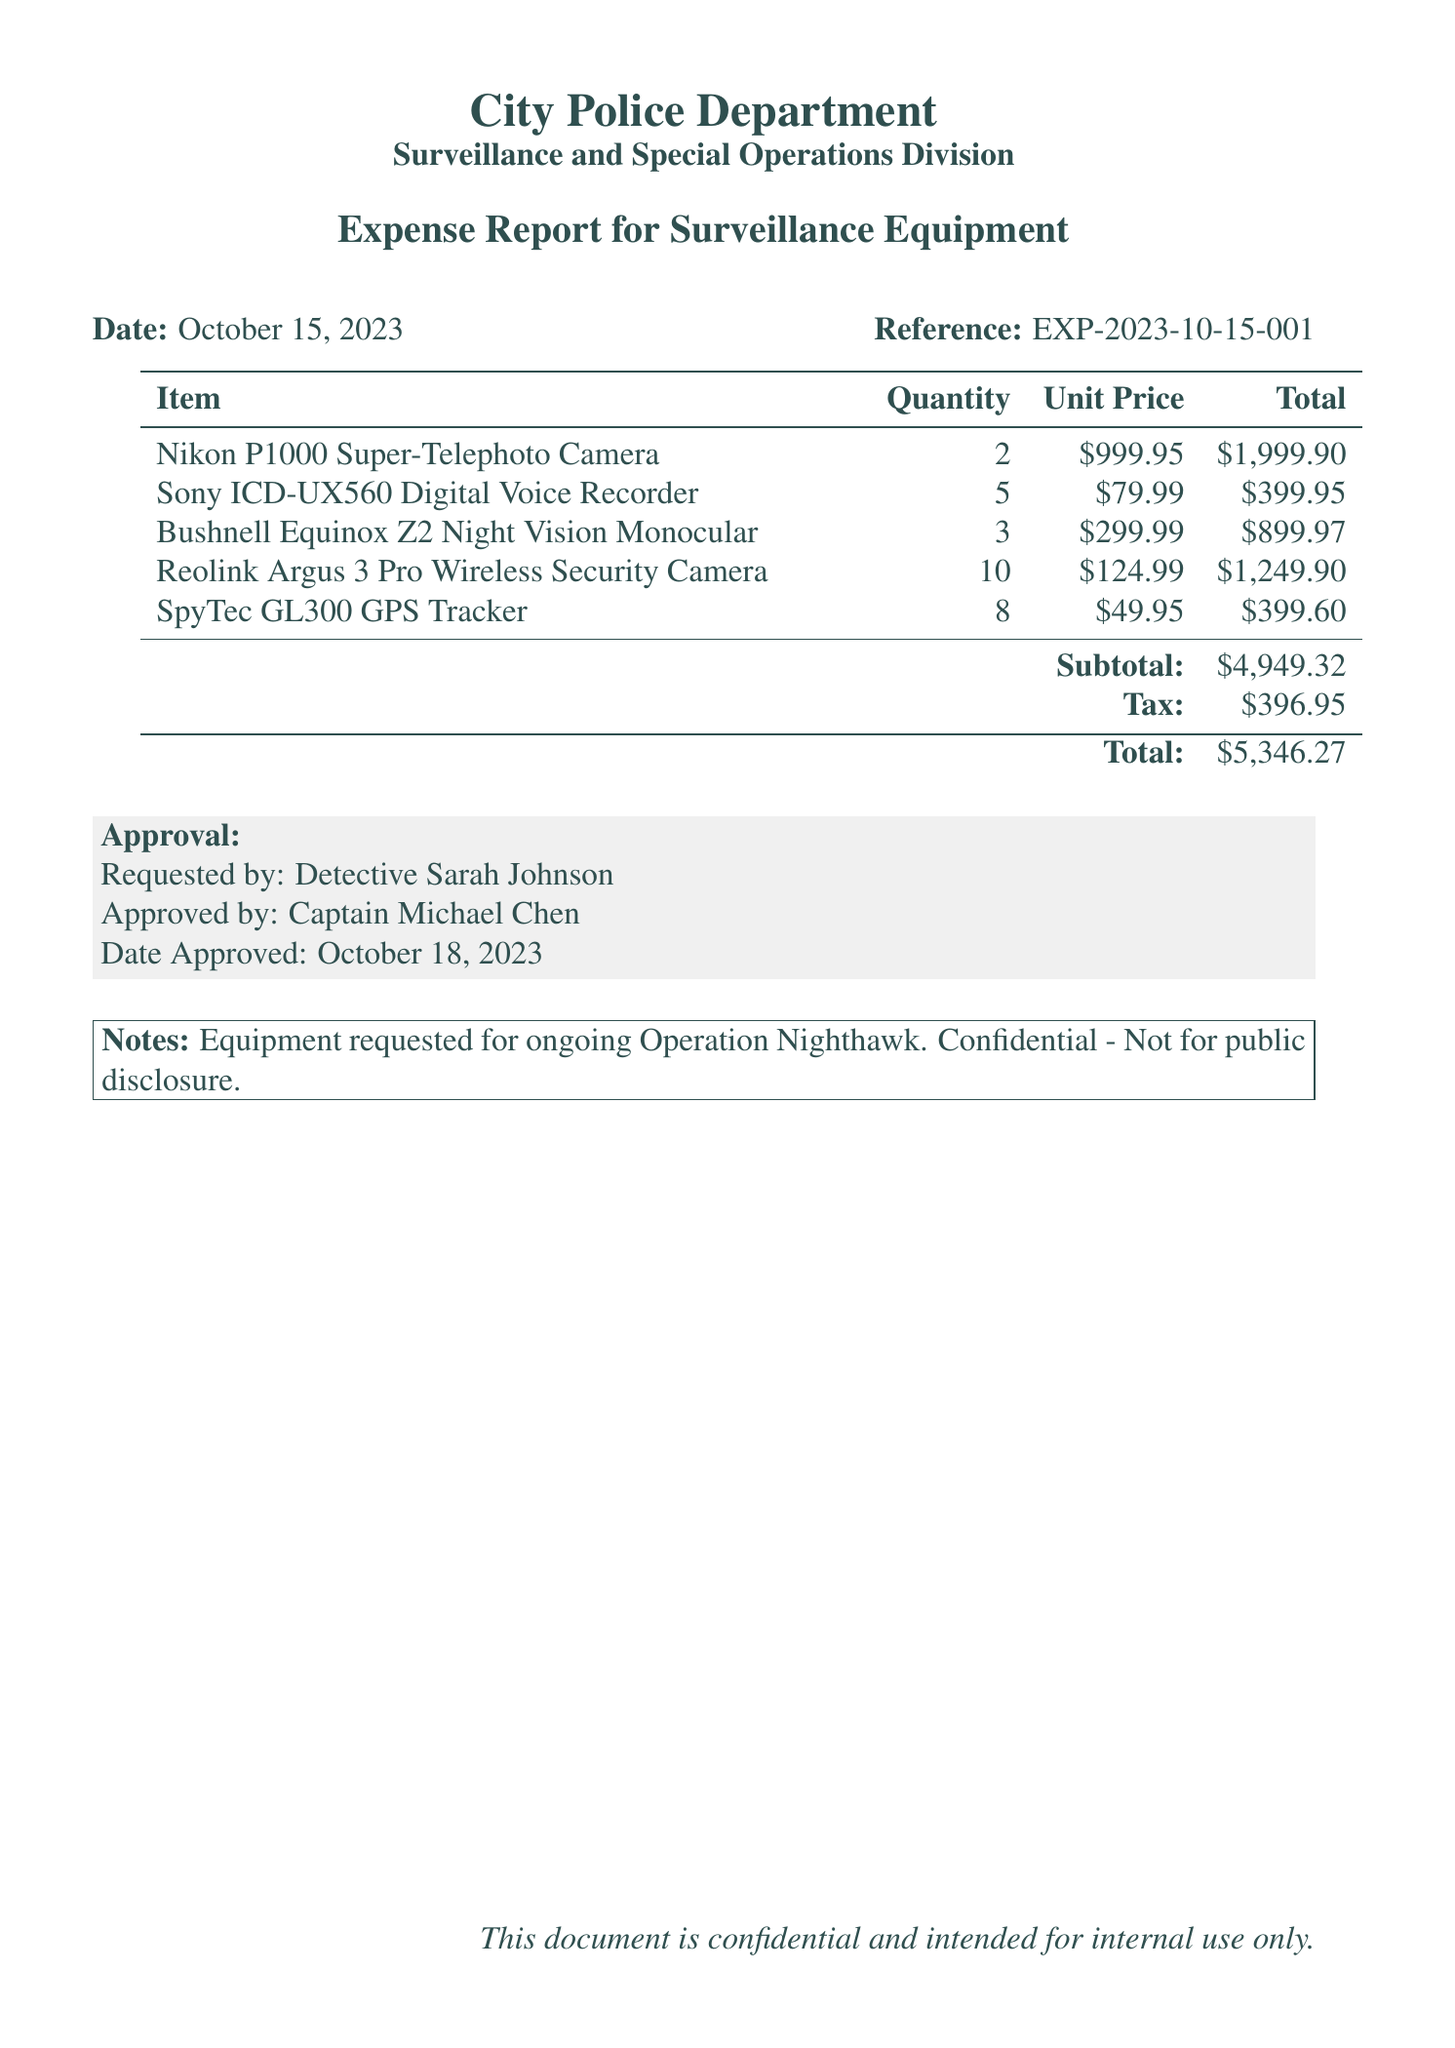what is the date of the expense report? The date is specified clearly at the top of the document.
Answer: October 15, 2023 who requested the equipment? The name of the person who requested the equipment is mentioned in the approval section.
Answer: Detective Sarah Johnson how many items were purchased in total? The total quantity of items can be calculated from the quantities listed in the document.
Answer: 28 what is the subtotal amount? The subtotal amount is clearly stated in the document.
Answer: $4,949.32 what is the total cost including tax? The total cost including tax is listed at the end of the document.
Answer: $5,346.27 who approved the expense report? The approver's name is given in the approval section of the document.
Answer: Captain Michael Chen how many Reolink Argus 3 Pro Wireless Security Cameras were purchased? The quantity of this specific item is listed in the table of items.
Answer: 10 what is the tax amount on the purchase? The tax amount is provided in the total calculations.
Answer: $396.95 what is the purpose of the equipment purchase? The purpose of the equipment purchase is noted in the document under the notes section.
Answer: Operation Nighthawk 